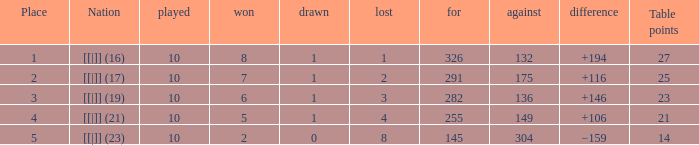What number of games experienced a 175-point shortfall? 1.0. 